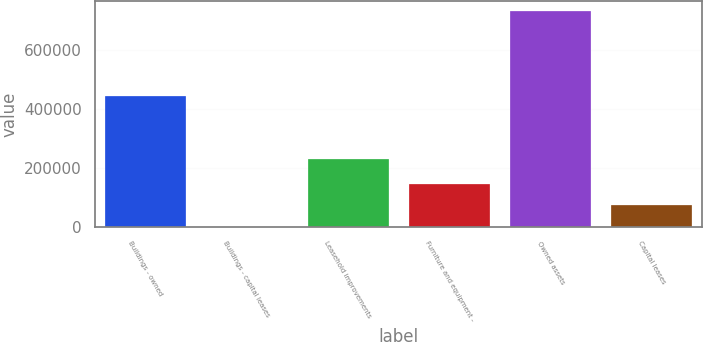<chart> <loc_0><loc_0><loc_500><loc_500><bar_chart><fcel>Buildings - owned<fcel>Buildings - capital leases<fcel>Leasehold improvements<fcel>Furniture and equipment -<fcel>Owned assets<fcel>Capital leases<nl><fcel>443507<fcel>1108<fcel>229919<fcel>147349<fcel>732315<fcel>74228.7<nl></chart> 